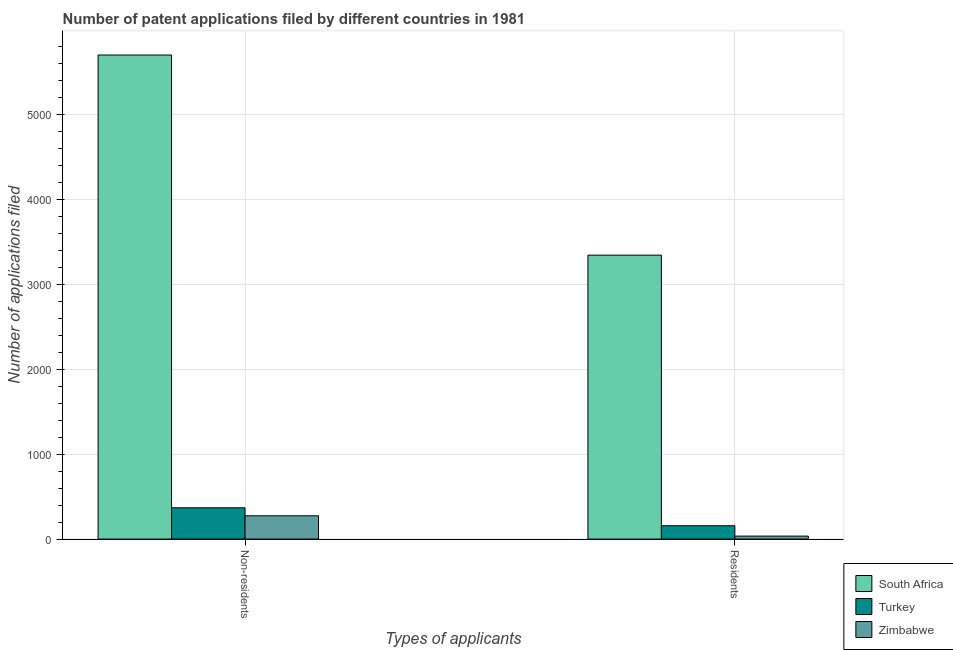How many groups of bars are there?
Your answer should be very brief. 2. Are the number of bars on each tick of the X-axis equal?
Offer a very short reply. Yes. What is the label of the 1st group of bars from the left?
Your answer should be very brief. Non-residents. What is the number of patent applications by non residents in Zimbabwe?
Your answer should be very brief. 274. Across all countries, what is the maximum number of patent applications by residents?
Your answer should be compact. 3340. Across all countries, what is the minimum number of patent applications by non residents?
Your answer should be compact. 274. In which country was the number of patent applications by non residents maximum?
Ensure brevity in your answer.  South Africa. In which country was the number of patent applications by residents minimum?
Your answer should be very brief. Zimbabwe. What is the total number of patent applications by non residents in the graph?
Offer a terse response. 6336. What is the difference between the number of patent applications by non residents in Zimbabwe and that in Turkey?
Provide a short and direct response. -94. What is the difference between the number of patent applications by non residents in Zimbabwe and the number of patent applications by residents in Turkey?
Offer a very short reply. 117. What is the average number of patent applications by non residents per country?
Your answer should be very brief. 2112. What is the difference between the number of patent applications by residents and number of patent applications by non residents in Zimbabwe?
Offer a very short reply. -239. In how many countries, is the number of patent applications by residents greater than 4400 ?
Provide a succinct answer. 0. What is the ratio of the number of patent applications by non residents in South Africa to that in Turkey?
Keep it short and to the point. 15.47. In how many countries, is the number of patent applications by non residents greater than the average number of patent applications by non residents taken over all countries?
Keep it short and to the point. 1. What does the 2nd bar from the left in Residents represents?
Give a very brief answer. Turkey. What does the 1st bar from the right in Residents represents?
Your answer should be very brief. Zimbabwe. Are all the bars in the graph horizontal?
Give a very brief answer. No. How many countries are there in the graph?
Give a very brief answer. 3. Are the values on the major ticks of Y-axis written in scientific E-notation?
Your answer should be very brief. No. Does the graph contain any zero values?
Make the answer very short. No. How many legend labels are there?
Provide a short and direct response. 3. What is the title of the graph?
Ensure brevity in your answer.  Number of patent applications filed by different countries in 1981. Does "Mali" appear as one of the legend labels in the graph?
Make the answer very short. No. What is the label or title of the X-axis?
Your response must be concise. Types of applicants. What is the label or title of the Y-axis?
Offer a very short reply. Number of applications filed. What is the Number of applications filed of South Africa in Non-residents?
Your response must be concise. 5694. What is the Number of applications filed in Turkey in Non-residents?
Offer a very short reply. 368. What is the Number of applications filed of Zimbabwe in Non-residents?
Make the answer very short. 274. What is the Number of applications filed in South Africa in Residents?
Provide a succinct answer. 3340. What is the Number of applications filed in Turkey in Residents?
Make the answer very short. 157. Across all Types of applicants, what is the maximum Number of applications filed of South Africa?
Keep it short and to the point. 5694. Across all Types of applicants, what is the maximum Number of applications filed in Turkey?
Your answer should be compact. 368. Across all Types of applicants, what is the maximum Number of applications filed of Zimbabwe?
Offer a terse response. 274. Across all Types of applicants, what is the minimum Number of applications filed in South Africa?
Give a very brief answer. 3340. Across all Types of applicants, what is the minimum Number of applications filed of Turkey?
Provide a succinct answer. 157. Across all Types of applicants, what is the minimum Number of applications filed in Zimbabwe?
Your answer should be compact. 35. What is the total Number of applications filed of South Africa in the graph?
Make the answer very short. 9034. What is the total Number of applications filed of Turkey in the graph?
Keep it short and to the point. 525. What is the total Number of applications filed of Zimbabwe in the graph?
Make the answer very short. 309. What is the difference between the Number of applications filed in South Africa in Non-residents and that in Residents?
Your answer should be very brief. 2354. What is the difference between the Number of applications filed in Turkey in Non-residents and that in Residents?
Ensure brevity in your answer.  211. What is the difference between the Number of applications filed of Zimbabwe in Non-residents and that in Residents?
Provide a succinct answer. 239. What is the difference between the Number of applications filed in South Africa in Non-residents and the Number of applications filed in Turkey in Residents?
Your answer should be very brief. 5537. What is the difference between the Number of applications filed of South Africa in Non-residents and the Number of applications filed of Zimbabwe in Residents?
Your answer should be very brief. 5659. What is the difference between the Number of applications filed of Turkey in Non-residents and the Number of applications filed of Zimbabwe in Residents?
Provide a short and direct response. 333. What is the average Number of applications filed of South Africa per Types of applicants?
Your answer should be very brief. 4517. What is the average Number of applications filed of Turkey per Types of applicants?
Make the answer very short. 262.5. What is the average Number of applications filed in Zimbabwe per Types of applicants?
Ensure brevity in your answer.  154.5. What is the difference between the Number of applications filed in South Africa and Number of applications filed in Turkey in Non-residents?
Ensure brevity in your answer.  5326. What is the difference between the Number of applications filed in South Africa and Number of applications filed in Zimbabwe in Non-residents?
Your answer should be very brief. 5420. What is the difference between the Number of applications filed in Turkey and Number of applications filed in Zimbabwe in Non-residents?
Your answer should be compact. 94. What is the difference between the Number of applications filed in South Africa and Number of applications filed in Turkey in Residents?
Your response must be concise. 3183. What is the difference between the Number of applications filed in South Africa and Number of applications filed in Zimbabwe in Residents?
Offer a very short reply. 3305. What is the difference between the Number of applications filed of Turkey and Number of applications filed of Zimbabwe in Residents?
Offer a terse response. 122. What is the ratio of the Number of applications filed of South Africa in Non-residents to that in Residents?
Give a very brief answer. 1.7. What is the ratio of the Number of applications filed of Turkey in Non-residents to that in Residents?
Offer a very short reply. 2.34. What is the ratio of the Number of applications filed in Zimbabwe in Non-residents to that in Residents?
Ensure brevity in your answer.  7.83. What is the difference between the highest and the second highest Number of applications filed of South Africa?
Offer a terse response. 2354. What is the difference between the highest and the second highest Number of applications filed in Turkey?
Offer a very short reply. 211. What is the difference between the highest and the second highest Number of applications filed in Zimbabwe?
Offer a terse response. 239. What is the difference between the highest and the lowest Number of applications filed of South Africa?
Provide a succinct answer. 2354. What is the difference between the highest and the lowest Number of applications filed of Turkey?
Make the answer very short. 211. What is the difference between the highest and the lowest Number of applications filed in Zimbabwe?
Give a very brief answer. 239. 